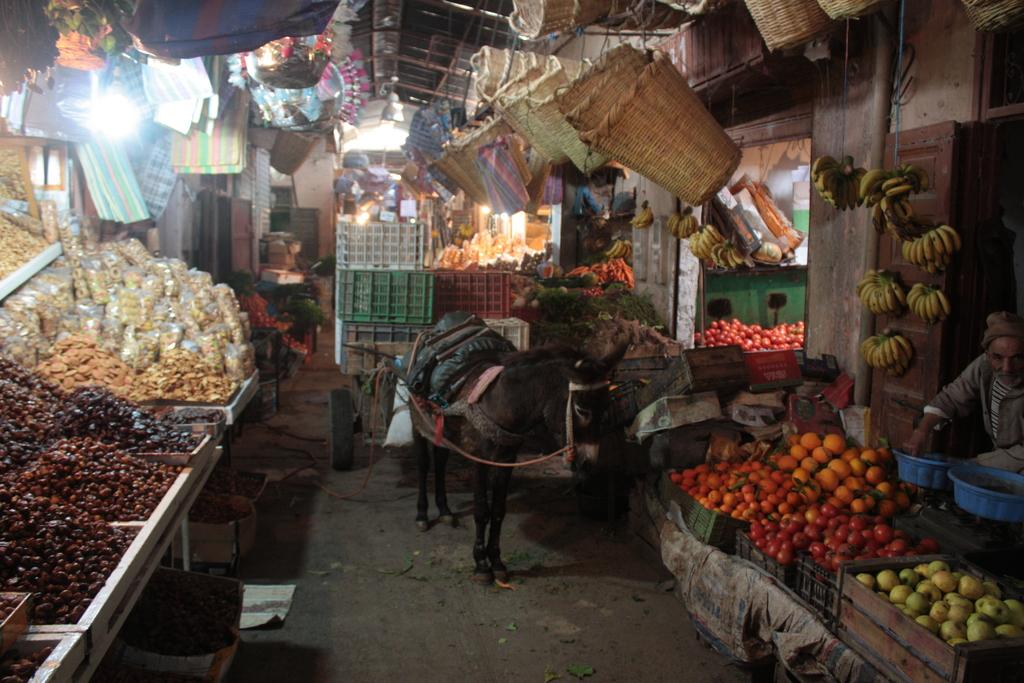What animal is in front of the store in the image? There is a donkey in front of the store in the image. Can you describe the person in the image? There is a person in the image, but their specific appearance or actions are not mentioned in the facts. What type of items are present in the image? Fruits, baskets, and bags are present in the image. What else can be seen in the image? Lights are visible in the image. How many women are present in the image, and what are they doing? The facts provided do not mention any women in the image, so we cannot answer this question. Can you describe the fear that the donkey is experiencing in the image? The facts provided do not mention any emotions or feelings of the donkey, so we cannot answer this question. 